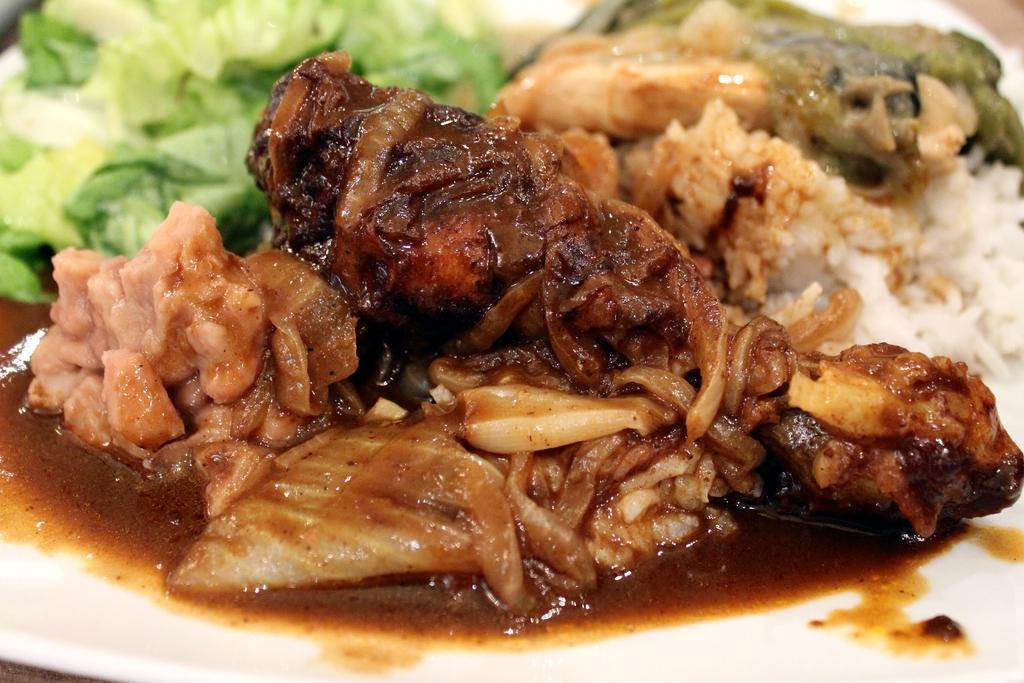In one or two sentences, can you explain what this image depicts? In the image,there is a food item placed on a plate and served,there are vegetables,cooked meat and rice are kept on the plate. 